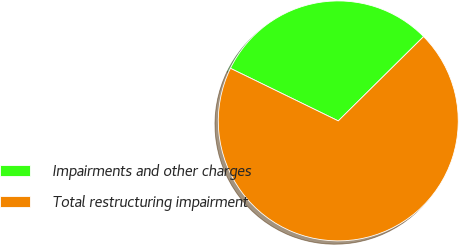<chart> <loc_0><loc_0><loc_500><loc_500><pie_chart><fcel>Impairments and other charges<fcel>Total restructuring impairment<nl><fcel>30.37%<fcel>69.63%<nl></chart> 